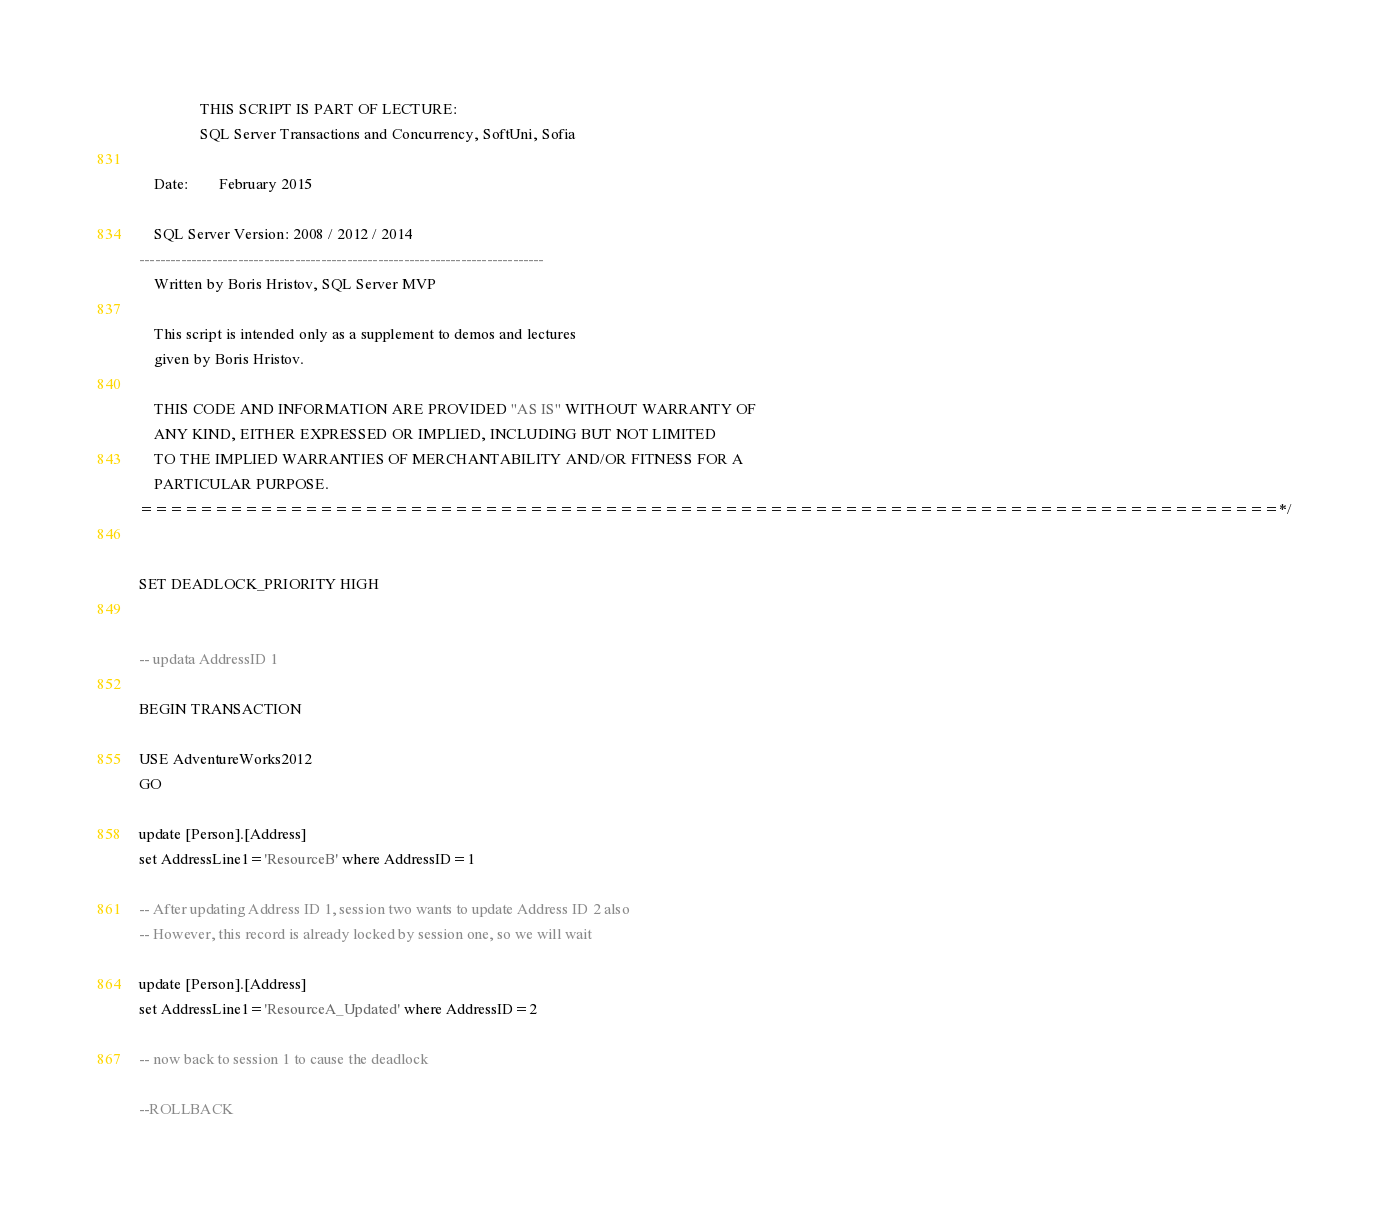Convert code to text. <code><loc_0><loc_0><loc_500><loc_500><_SQL_>
				THIS SCRIPT IS PART OF LECTURE: 
				SQL Server Transactions and Concurrency, SoftUni, Sofia

	Date:		February 2015

	SQL Server Version: 2008 / 2012 / 2014
------------------------------------------------------------------------------
	Written by Boris Hristov, SQL Server MVP

	This script is intended only as a supplement to demos and lectures
	given by Boris Hristov.  
  
	THIS CODE AND INFORMATION ARE PROVIDED "AS IS" WITHOUT WARRANTY OF 
	ANY KIND, EITHER EXPRESSED OR IMPLIED, INCLUDING BUT NOT LIMITED 
	TO THE IMPLIED WARRANTIES OF MERCHANTABILITY AND/OR FITNESS FOR A
	PARTICULAR PURPOSE.
============================================================================*/


SET DEADLOCK_PRIORITY HIGH


-- updata AddressID 1 

BEGIN TRANSACTION

USE AdventureWorks2012
GO

update [Person].[Address]
set AddressLine1='ResourceB' where AddressID=1

-- After updating Address ID 1, session two wants to update Address ID 2 also
-- However, this record is already locked by session one, so we will wait

update [Person].[Address]
set AddressLine1='ResourceA_Updated' where AddressID=2

-- now back to session 1 to cause the deadlock

--ROLLBACK
</code> 